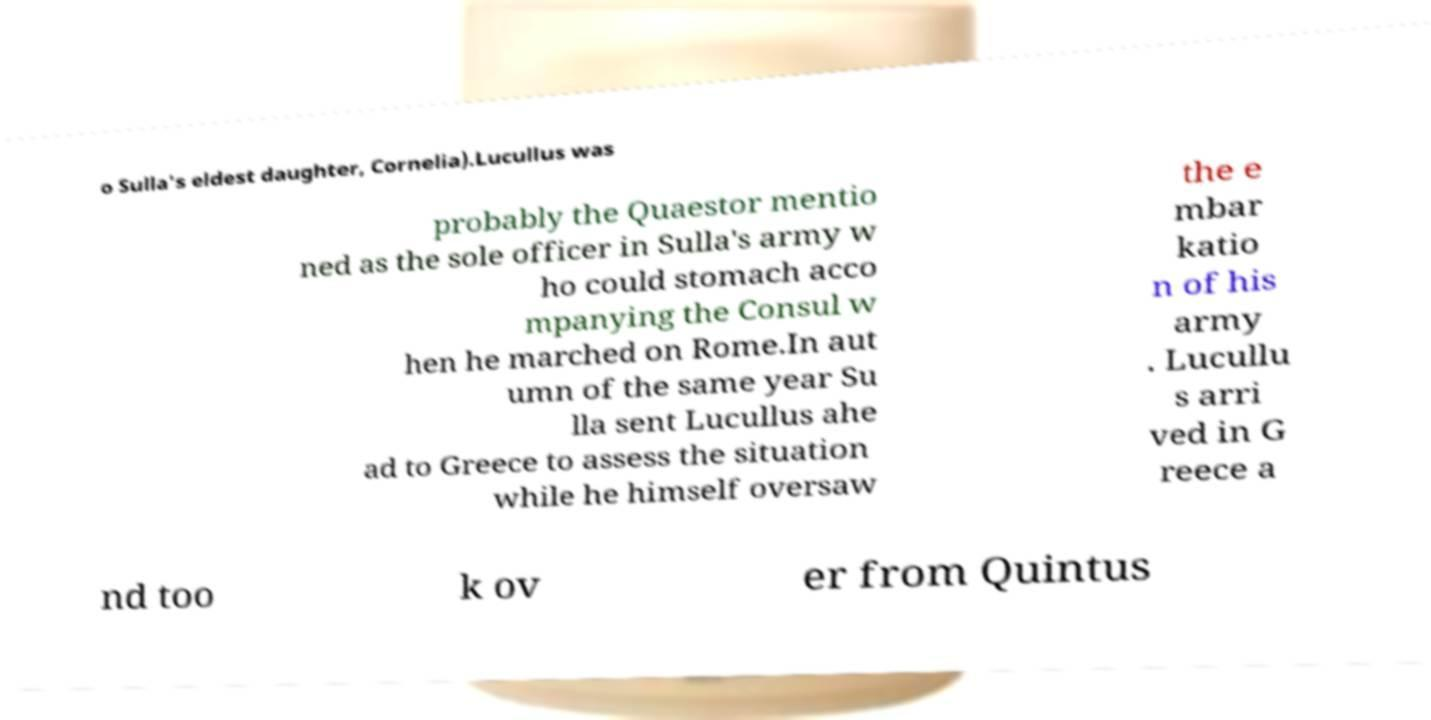For documentation purposes, I need the text within this image transcribed. Could you provide that? o Sulla's eldest daughter, Cornelia).Lucullus was probably the Quaestor mentio ned as the sole officer in Sulla's army w ho could stomach acco mpanying the Consul w hen he marched on Rome.In aut umn of the same year Su lla sent Lucullus ahe ad to Greece to assess the situation while he himself oversaw the e mbar katio n of his army . Lucullu s arri ved in G reece a nd too k ov er from Quintus 